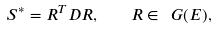Convert formula to latex. <formula><loc_0><loc_0><loc_500><loc_500>S ^ { * } = R ^ { T } D R , \quad R \in \ G ( E ) ,</formula> 